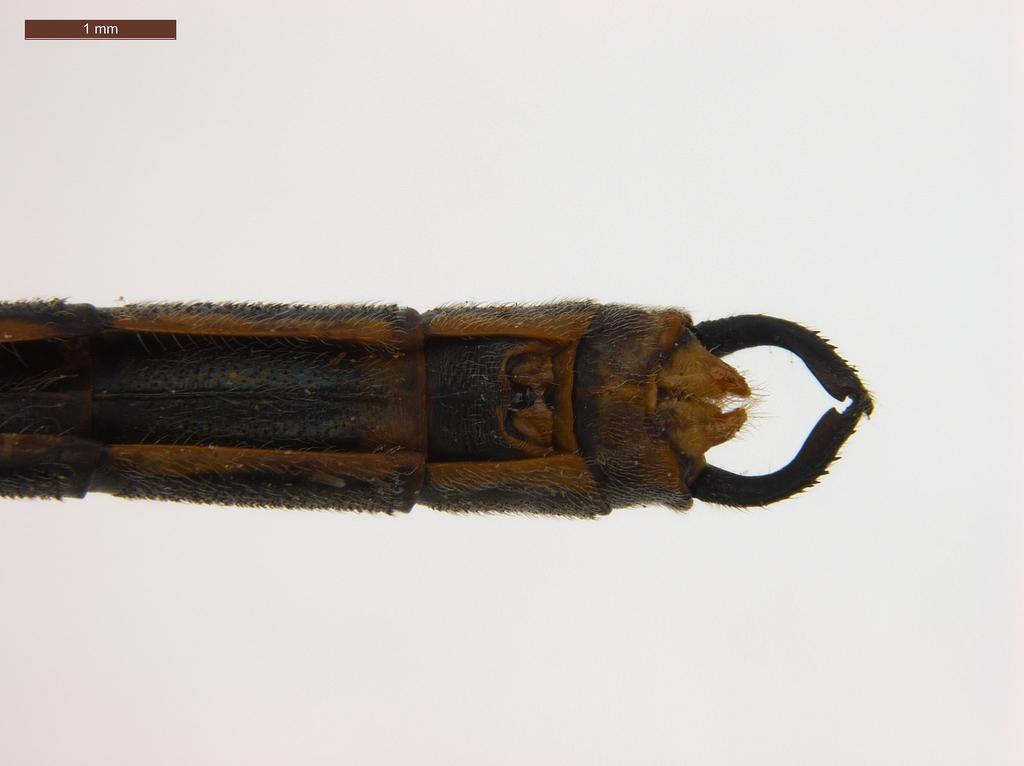What is the main subject in the center of the image? There is an object in the center of the image. Can you describe any text that is visible in the image? There is text on the top left of the image. How many cattle are resting on the bed in the image? There are no cattle or beds present in the image. What type of rhythm can be heard in the image? There is no sound or rhythm present in the image. 